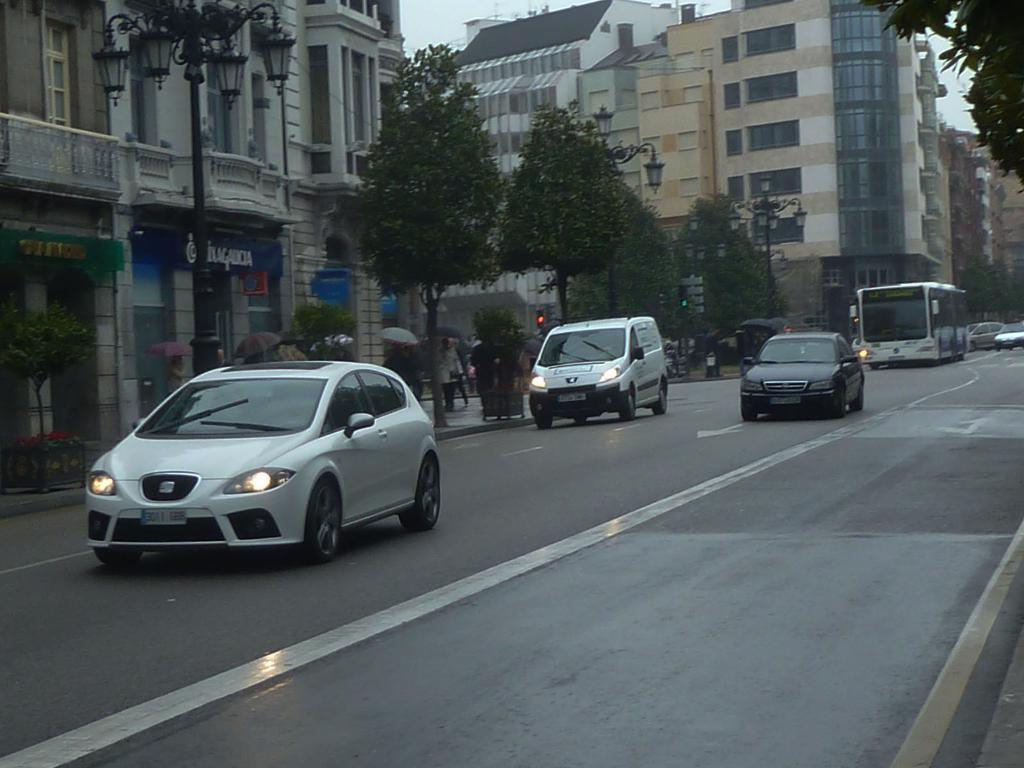What type of structures can be seen in the image? There are buildings in the image. What architectural features can be observed on the buildings? Windows are visible in the image. What type of vegetation is present in the image? There are trees in the image. What type of street infrastructure is visible in the image? There are light poles in the image. What type of establishments can be found in the image? There are stores in the image. What type of traffic control device is present in the image? There is a traffic signal in the image. Who is present in the image? There are people in the image. What are some people doing in the image? Some people are holding umbrellas. What type of transportation is visible in the image? There are vehicles on the road in the image. Can you tell me how many kitties are playing with dolls in the image? There are no kitties or dolls present in the image. What example of a rare animal can be seen in the image? There is no rare animal present in the image. 